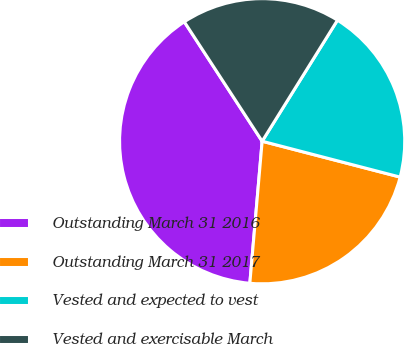Convert chart. <chart><loc_0><loc_0><loc_500><loc_500><pie_chart><fcel>Outstanding March 31 2016<fcel>Outstanding March 31 2017<fcel>Vested and expected to vest<fcel>Vested and exercisable March<nl><fcel>39.43%<fcel>22.33%<fcel>20.19%<fcel>18.05%<nl></chart> 